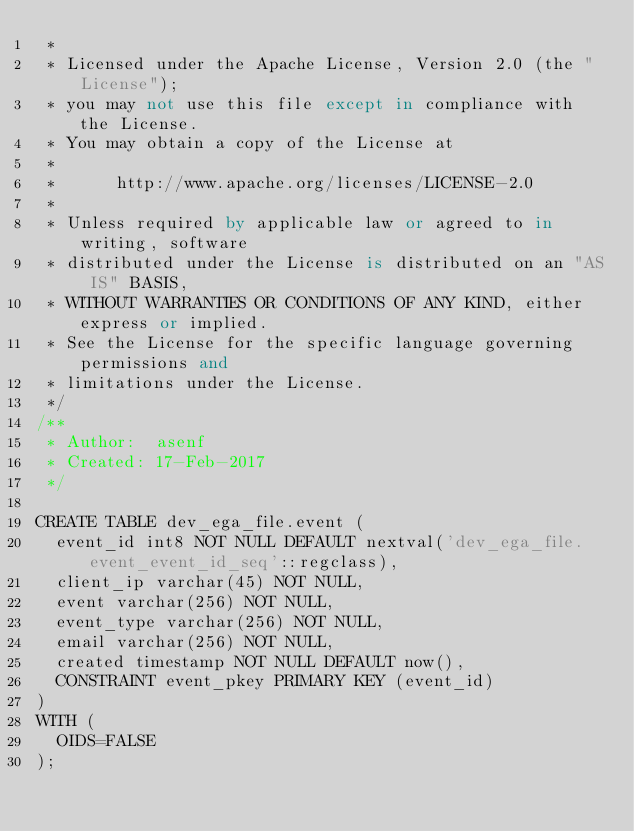<code> <loc_0><loc_0><loc_500><loc_500><_SQL_> *
 * Licensed under the Apache License, Version 2.0 (the "License");
 * you may not use this file except in compliance with the License.
 * You may obtain a copy of the License at
 *
 *      http://www.apache.org/licenses/LICENSE-2.0
 *
 * Unless required by applicable law or agreed to in writing, software
 * distributed under the License is distributed on an "AS IS" BASIS,
 * WITHOUT WARRANTIES OR CONDITIONS OF ANY KIND, either express or implied.
 * See the License for the specific language governing permissions and
 * limitations under the License.
 */
/**
 * Author:  asenf
 * Created: 17-Feb-2017
 */

CREATE TABLE dev_ega_file.event (
	event_id int8 NOT NULL DEFAULT nextval('dev_ega_file.event_event_id_seq'::regclass),
	client_ip varchar(45) NOT NULL,
	event varchar(256) NOT NULL,
	event_type varchar(256) NOT NULL,
	email varchar(256) NOT NULL,
	created timestamp NOT NULL DEFAULT now(),
	CONSTRAINT event_pkey PRIMARY KEY (event_id)
)
WITH (
	OIDS=FALSE
);</code> 